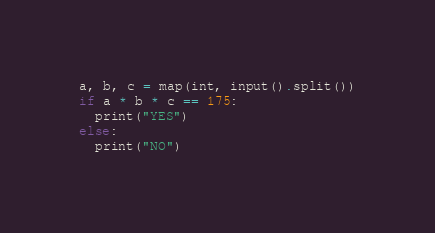Convert code to text. <code><loc_0><loc_0><loc_500><loc_500><_Python_>a, b, c = map(int, input().split())
if a * b * c == 175:
  print("YES")
else:
  print("NO")</code> 